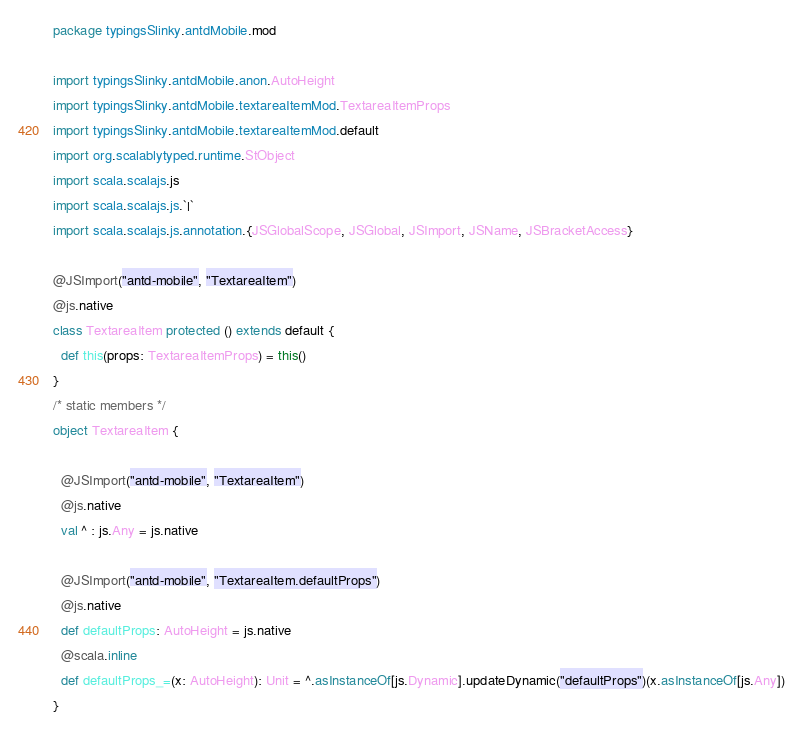<code> <loc_0><loc_0><loc_500><loc_500><_Scala_>package typingsSlinky.antdMobile.mod

import typingsSlinky.antdMobile.anon.AutoHeight
import typingsSlinky.antdMobile.textareaItemMod.TextareaItemProps
import typingsSlinky.antdMobile.textareaItemMod.default
import org.scalablytyped.runtime.StObject
import scala.scalajs.js
import scala.scalajs.js.`|`
import scala.scalajs.js.annotation.{JSGlobalScope, JSGlobal, JSImport, JSName, JSBracketAccess}

@JSImport("antd-mobile", "TextareaItem")
@js.native
class TextareaItem protected () extends default {
  def this(props: TextareaItemProps) = this()
}
/* static members */
object TextareaItem {
  
  @JSImport("antd-mobile", "TextareaItem")
  @js.native
  val ^ : js.Any = js.native
  
  @JSImport("antd-mobile", "TextareaItem.defaultProps")
  @js.native
  def defaultProps: AutoHeight = js.native
  @scala.inline
  def defaultProps_=(x: AutoHeight): Unit = ^.asInstanceOf[js.Dynamic].updateDynamic("defaultProps")(x.asInstanceOf[js.Any])
}
</code> 